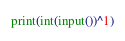Convert code to text. <code><loc_0><loc_0><loc_500><loc_500><_Python_>print(int(input())^1)</code> 